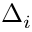Convert formula to latex. <formula><loc_0><loc_0><loc_500><loc_500>\Delta _ { i }</formula> 